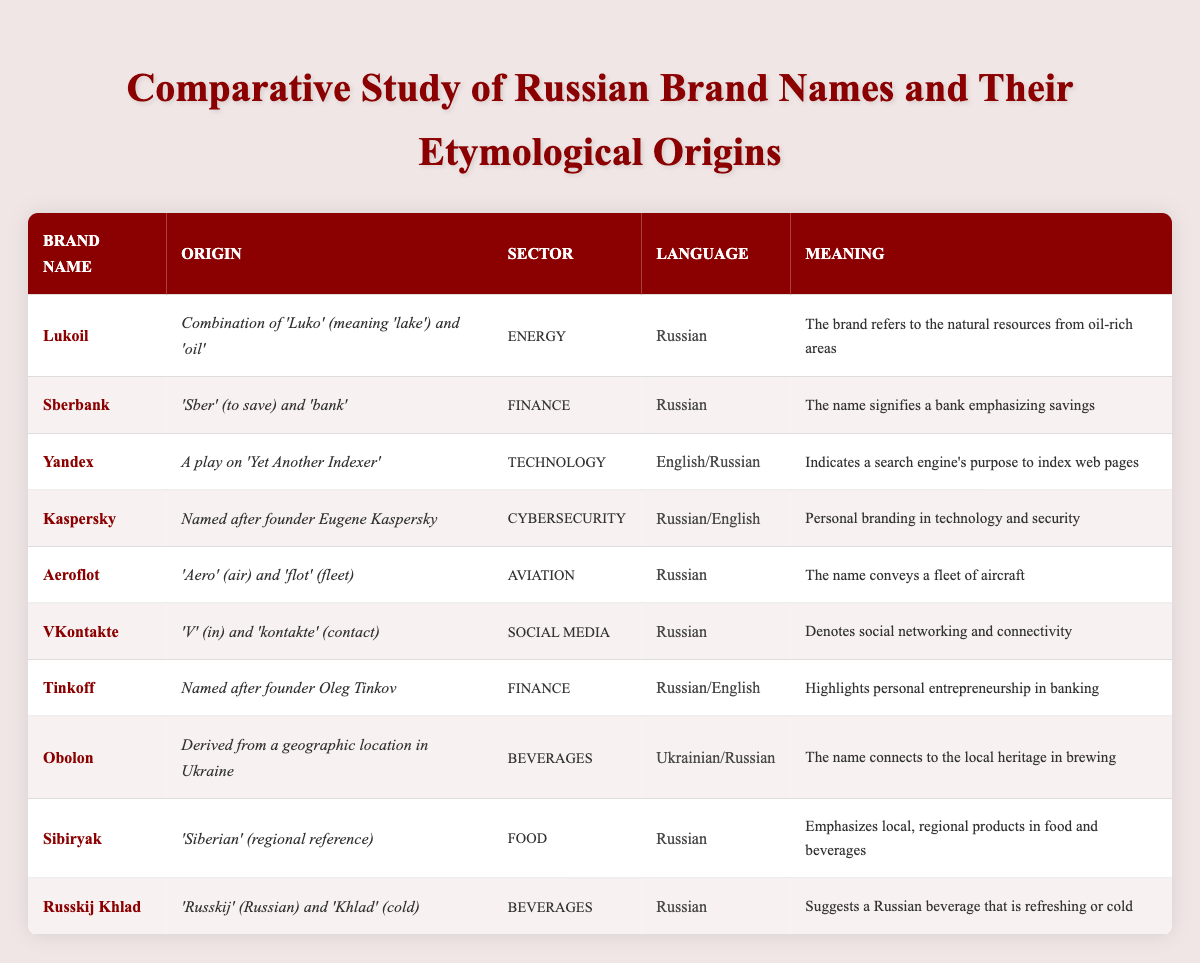What's the brand name with an origin related to a geographic location in Ukraine? The table lists "Obolon" as a brand name. The origin indicates it is derived from a geographic location in Ukraine.
Answer: Obolon Which brand name in the finance sector emphasizes the concept of savings? "Sberbank" is the brand name listed under the finance sector that signifies a bank emphasizing savings according to its origin.
Answer: Sberbank How many brands are named after their founders? There are two brands named after their founders: "Kaspersky" and "Tinkoff." Thus, the count of such brands is found by checking the origin column for names explicitly stating the founder's name.
Answer: 2 What is the origin of the brand name "Yandex"? The origin of "Yandex" is explained as a play on 'Yet Another Indexer.' This information is directly referenced in the origin column of the table.
Answer: A play on 'Yet Another Indexer' Which brand names are associated with both Russian and English languages? "Yandex" and "Kaspersky" are the brand names that indicate associations with both Russian and English languages as noted in the language column.
Answer: Yandex, Kaspersky What is the common theme in the meanings of "Sibiryak" and "Russkij Khlad"? Both brand names highlight local or regional references tied to their products; "Sibiryak" emphasizes local Siberian products, while "Russkij Khlad" suggests a refreshing Russian beverage, indicating a focus on locality.
Answer: Local/regional references Is the origin of "Aeroflot" entirely in the Russian language? Yes, the origin of "Aeroflot" consists entirely of Russian words, "Aero" (air) and "flot" (fleet). This can be confirmed by observing the language column, which lists it as Russian.
Answer: Yes Which sector does the brand "VKontakte" belong to, and what does its name signify? "VKontakte" belongs to the Social Media sector, and its name signifies social networking and connectivity as described in its meaning.
Answer: Social Media; signifies social networking and connectivity What portion of the brands listed derive their names from personal branding or founders? The brands "Kaspersky" and "Tinkoff" derive their names from founders, representing 20% of the total 10 brands listed. This is calculated by identifying the number of founder-based names and dividing it by the total number of brands.
Answer: 20% Which brand name suggests its connection to energy resources? The brand "Lukoil" suggests a connection to energy resources, specifically referring to natural resources from oil-rich areas, as stated in its meaning.
Answer: Lukoil What is the meaning associated with the brand name "Sberbank"? The meaning associated with "Sberbank" indicates a bank emphasizing savings, clearly laid out in the meaning column of the table.
Answer: A bank emphasizing savings 